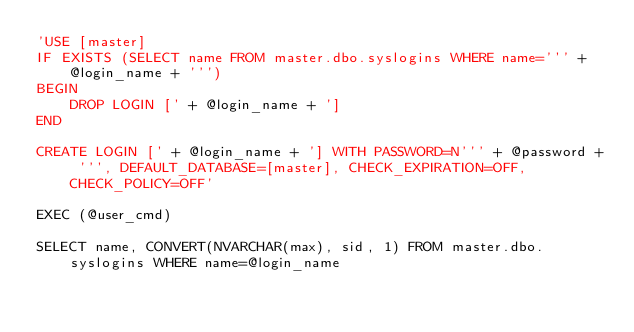<code> <loc_0><loc_0><loc_500><loc_500><_SQL_>'USE [master]
IF EXISTS (SELECT name FROM master.dbo.syslogins WHERE name=''' + @login_name + ''')
BEGIN
	DROP LOGIN [' + @login_name + ']
END

CREATE LOGIN [' + @login_name + '] WITH PASSWORD=N''' + @password + ''', DEFAULT_DATABASE=[master], CHECK_EXPIRATION=OFF, CHECK_POLICY=OFF'

EXEC (@user_cmd)

SELECT name, CONVERT(NVARCHAR(max), sid, 1) FROM master.dbo.syslogins WHERE name=@login_name
</code> 